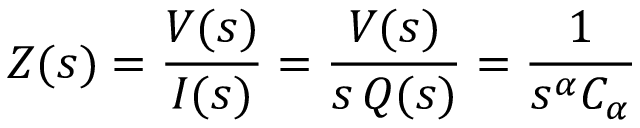<formula> <loc_0><loc_0><loc_500><loc_500>Z ( s ) = \frac { V ( s ) } { I ( s ) } = \frac { V ( s ) } { s \, Q ( s ) } = \frac { 1 } { s ^ { \alpha } C _ { \alpha } }</formula> 